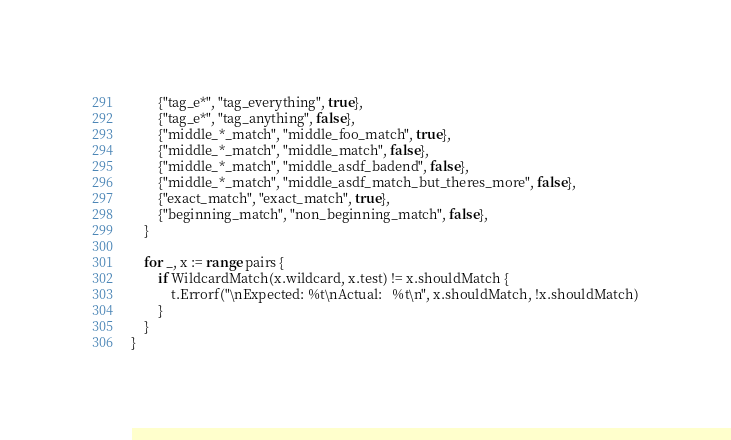<code> <loc_0><loc_0><loc_500><loc_500><_Go_>		{"tag_e*", "tag_everything", true},
		{"tag_e*", "tag_anything", false},
		{"middle_*_match", "middle_foo_match", true},
		{"middle_*_match", "middle_match", false},
		{"middle_*_match", "middle_asdf_badend", false},
		{"middle_*_match", "middle_asdf_match_but_theres_more", false},
		{"exact_match", "exact_match", true},
		{"beginning_match", "non_beginning_match", false},
	}

	for _, x := range pairs {
		if WildcardMatch(x.wildcard, x.test) != x.shouldMatch {
			t.Errorf("\nExpected: %t\nActual:   %t\n", x.shouldMatch, !x.shouldMatch)
		}
	}
}
</code> 